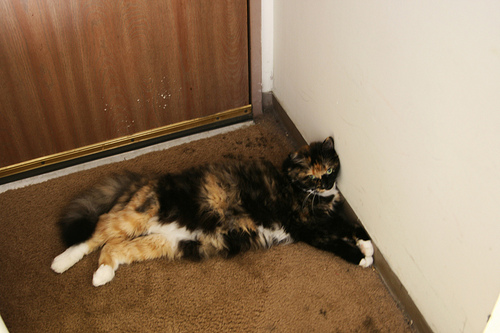<image>
Can you confirm if the cat is in front of the scuffs? Yes. The cat is positioned in front of the scuffs, appearing closer to the camera viewpoint. 